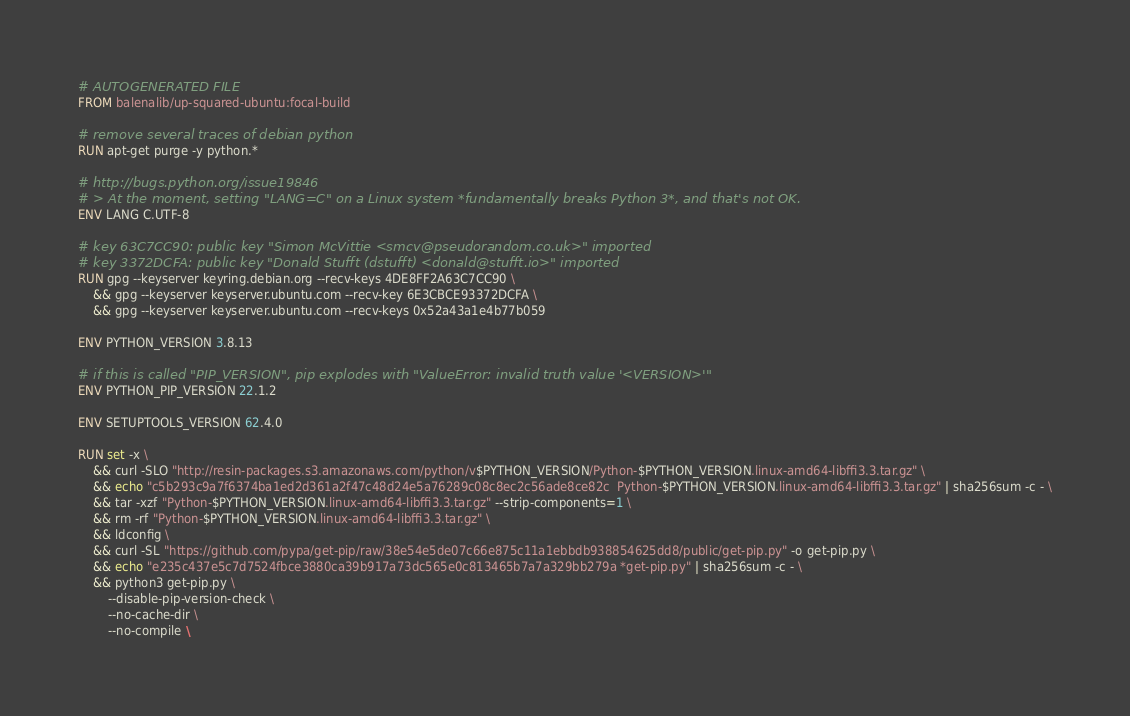Convert code to text. <code><loc_0><loc_0><loc_500><loc_500><_Dockerfile_># AUTOGENERATED FILE
FROM balenalib/up-squared-ubuntu:focal-build

# remove several traces of debian python
RUN apt-get purge -y python.*

# http://bugs.python.org/issue19846
# > At the moment, setting "LANG=C" on a Linux system *fundamentally breaks Python 3*, and that's not OK.
ENV LANG C.UTF-8

# key 63C7CC90: public key "Simon McVittie <smcv@pseudorandom.co.uk>" imported
# key 3372DCFA: public key "Donald Stufft (dstufft) <donald@stufft.io>" imported
RUN gpg --keyserver keyring.debian.org --recv-keys 4DE8FF2A63C7CC90 \
	&& gpg --keyserver keyserver.ubuntu.com --recv-key 6E3CBCE93372DCFA \
	&& gpg --keyserver keyserver.ubuntu.com --recv-keys 0x52a43a1e4b77b059

ENV PYTHON_VERSION 3.8.13

# if this is called "PIP_VERSION", pip explodes with "ValueError: invalid truth value '<VERSION>'"
ENV PYTHON_PIP_VERSION 22.1.2

ENV SETUPTOOLS_VERSION 62.4.0

RUN set -x \
	&& curl -SLO "http://resin-packages.s3.amazonaws.com/python/v$PYTHON_VERSION/Python-$PYTHON_VERSION.linux-amd64-libffi3.3.tar.gz" \
	&& echo "c5b293c9a7f6374ba1ed2d361a2f47c48d24e5a76289c08c8ec2c56ade8ce82c  Python-$PYTHON_VERSION.linux-amd64-libffi3.3.tar.gz" | sha256sum -c - \
	&& tar -xzf "Python-$PYTHON_VERSION.linux-amd64-libffi3.3.tar.gz" --strip-components=1 \
	&& rm -rf "Python-$PYTHON_VERSION.linux-amd64-libffi3.3.tar.gz" \
	&& ldconfig \
	&& curl -SL "https://github.com/pypa/get-pip/raw/38e54e5de07c66e875c11a1ebbdb938854625dd8/public/get-pip.py" -o get-pip.py \
    && echo "e235c437e5c7d7524fbce3880ca39b917a73dc565e0c813465b7a7a329bb279a *get-pip.py" | sha256sum -c - \
    && python3 get-pip.py \
        --disable-pip-version-check \
        --no-cache-dir \
        --no-compile \</code> 